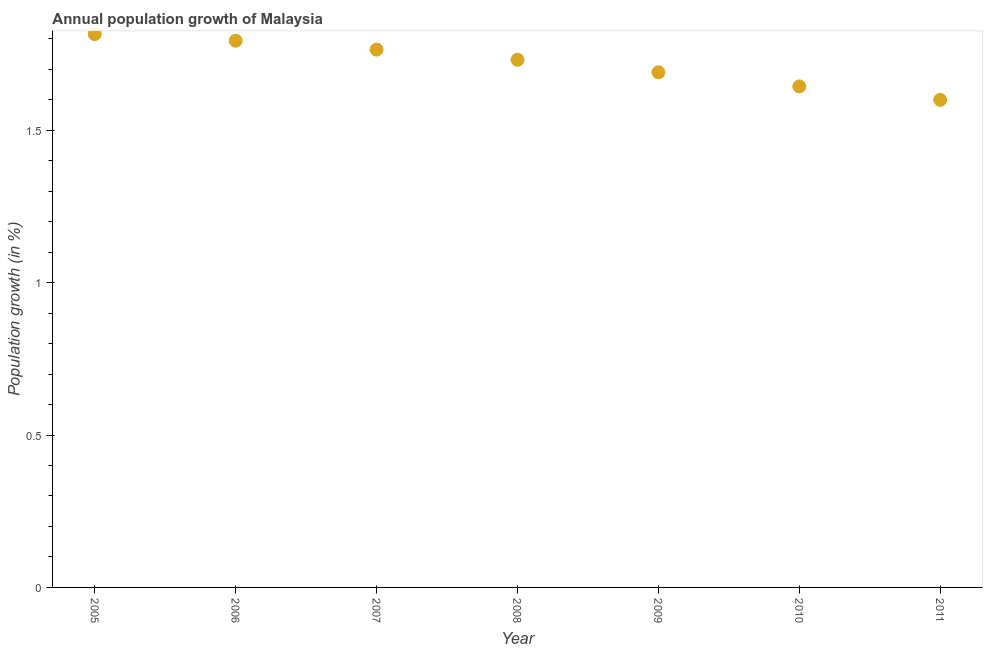What is the population growth in 2010?
Your response must be concise. 1.64. Across all years, what is the maximum population growth?
Your response must be concise. 1.82. Across all years, what is the minimum population growth?
Your answer should be very brief. 1.6. In which year was the population growth maximum?
Offer a terse response. 2005. What is the sum of the population growth?
Keep it short and to the point. 12.04. What is the difference between the population growth in 2006 and 2010?
Your answer should be very brief. 0.15. What is the average population growth per year?
Offer a terse response. 1.72. What is the median population growth?
Your response must be concise. 1.73. In how many years, is the population growth greater than 1.6 %?
Offer a terse response. 6. Do a majority of the years between 2009 and 2006 (inclusive) have population growth greater than 1.2 %?
Your answer should be compact. Yes. What is the ratio of the population growth in 2007 to that in 2009?
Make the answer very short. 1.04. Is the difference between the population growth in 2006 and 2008 greater than the difference between any two years?
Make the answer very short. No. What is the difference between the highest and the second highest population growth?
Ensure brevity in your answer.  0.02. Is the sum of the population growth in 2005 and 2008 greater than the maximum population growth across all years?
Ensure brevity in your answer.  Yes. What is the difference between the highest and the lowest population growth?
Provide a succinct answer. 0.22. In how many years, is the population growth greater than the average population growth taken over all years?
Give a very brief answer. 4. How many years are there in the graph?
Ensure brevity in your answer.  7. Does the graph contain any zero values?
Your answer should be very brief. No. Does the graph contain grids?
Ensure brevity in your answer.  No. What is the title of the graph?
Ensure brevity in your answer.  Annual population growth of Malaysia. What is the label or title of the X-axis?
Offer a very short reply. Year. What is the label or title of the Y-axis?
Provide a short and direct response. Population growth (in %). What is the Population growth (in %) in 2005?
Your answer should be very brief. 1.82. What is the Population growth (in %) in 2006?
Provide a succinct answer. 1.79. What is the Population growth (in %) in 2007?
Offer a very short reply. 1.76. What is the Population growth (in %) in 2008?
Your answer should be very brief. 1.73. What is the Population growth (in %) in 2009?
Provide a short and direct response. 1.69. What is the Population growth (in %) in 2010?
Provide a short and direct response. 1.64. What is the Population growth (in %) in 2011?
Your answer should be very brief. 1.6. What is the difference between the Population growth (in %) in 2005 and 2006?
Provide a succinct answer. 0.02. What is the difference between the Population growth (in %) in 2005 and 2007?
Ensure brevity in your answer.  0.05. What is the difference between the Population growth (in %) in 2005 and 2008?
Your answer should be compact. 0.08. What is the difference between the Population growth (in %) in 2005 and 2009?
Offer a terse response. 0.13. What is the difference between the Population growth (in %) in 2005 and 2010?
Your answer should be compact. 0.17. What is the difference between the Population growth (in %) in 2005 and 2011?
Your answer should be very brief. 0.22. What is the difference between the Population growth (in %) in 2006 and 2007?
Provide a short and direct response. 0.03. What is the difference between the Population growth (in %) in 2006 and 2008?
Provide a succinct answer. 0.06. What is the difference between the Population growth (in %) in 2006 and 2009?
Make the answer very short. 0.1. What is the difference between the Population growth (in %) in 2006 and 2010?
Offer a very short reply. 0.15. What is the difference between the Population growth (in %) in 2006 and 2011?
Offer a very short reply. 0.19. What is the difference between the Population growth (in %) in 2007 and 2008?
Give a very brief answer. 0.03. What is the difference between the Population growth (in %) in 2007 and 2009?
Offer a terse response. 0.07. What is the difference between the Population growth (in %) in 2007 and 2010?
Provide a succinct answer. 0.12. What is the difference between the Population growth (in %) in 2007 and 2011?
Give a very brief answer. 0.16. What is the difference between the Population growth (in %) in 2008 and 2009?
Offer a very short reply. 0.04. What is the difference between the Population growth (in %) in 2008 and 2010?
Provide a short and direct response. 0.09. What is the difference between the Population growth (in %) in 2008 and 2011?
Offer a very short reply. 0.13. What is the difference between the Population growth (in %) in 2009 and 2010?
Your answer should be very brief. 0.05. What is the difference between the Population growth (in %) in 2009 and 2011?
Your answer should be very brief. 0.09. What is the difference between the Population growth (in %) in 2010 and 2011?
Provide a short and direct response. 0.04. What is the ratio of the Population growth (in %) in 2005 to that in 2006?
Your answer should be compact. 1.01. What is the ratio of the Population growth (in %) in 2005 to that in 2008?
Your answer should be very brief. 1.05. What is the ratio of the Population growth (in %) in 2005 to that in 2009?
Provide a succinct answer. 1.07. What is the ratio of the Population growth (in %) in 2005 to that in 2010?
Ensure brevity in your answer.  1.1. What is the ratio of the Population growth (in %) in 2005 to that in 2011?
Offer a very short reply. 1.14. What is the ratio of the Population growth (in %) in 2006 to that in 2008?
Your answer should be very brief. 1.04. What is the ratio of the Population growth (in %) in 2006 to that in 2009?
Your answer should be very brief. 1.06. What is the ratio of the Population growth (in %) in 2006 to that in 2010?
Give a very brief answer. 1.09. What is the ratio of the Population growth (in %) in 2006 to that in 2011?
Provide a short and direct response. 1.12. What is the ratio of the Population growth (in %) in 2007 to that in 2008?
Offer a terse response. 1.02. What is the ratio of the Population growth (in %) in 2007 to that in 2009?
Offer a terse response. 1.04. What is the ratio of the Population growth (in %) in 2007 to that in 2010?
Provide a short and direct response. 1.07. What is the ratio of the Population growth (in %) in 2007 to that in 2011?
Keep it short and to the point. 1.1. What is the ratio of the Population growth (in %) in 2008 to that in 2010?
Ensure brevity in your answer.  1.05. What is the ratio of the Population growth (in %) in 2008 to that in 2011?
Ensure brevity in your answer.  1.08. What is the ratio of the Population growth (in %) in 2009 to that in 2010?
Provide a succinct answer. 1.03. What is the ratio of the Population growth (in %) in 2009 to that in 2011?
Your answer should be compact. 1.06. What is the ratio of the Population growth (in %) in 2010 to that in 2011?
Offer a very short reply. 1.03. 